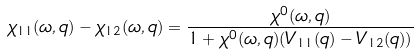Convert formula to latex. <formula><loc_0><loc_0><loc_500><loc_500>\chi _ { 1 1 } ( \omega , { q } ) - \chi _ { 1 2 } ( \omega , { q } ) = \frac { \chi ^ { 0 } ( \omega , { q } ) } { 1 + \chi ^ { 0 } ( \omega , { q } ) ( V _ { 1 1 } ( { q } ) - V _ { 1 2 } ( { q } ) ) }</formula> 